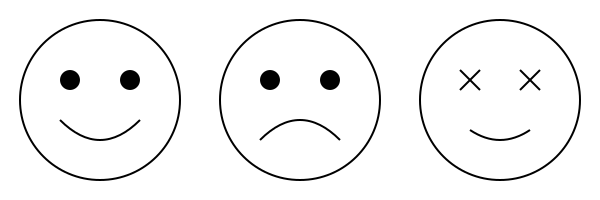As a theater director, you understand the importance of conveying emotions through facial expressions. Analyze the series of stylized face drawings above. Which of these expressions would be most appropriate for an actor portraying Konstantin Treplev during his final monologue in Chekhov's "The Seagull"? To answer this question, we need to consider the following steps:

1. Analyze the emotional expressions in the given drawings:
   a. Face 1 depicts joy or happiness (upturned mouth, open eyes)
   b. Face 2 shows sadness or melancholy (downturned mouth, drooping eyes)
   c. Face 3 represents anger or frustration (furrowed brow, tense mouth)

2. Recall the character of Konstantin Treplev in "The Seagull":
   - He is a young, aspiring playwright
   - He struggles with feelings of inadequacy and rejection
   - He is in love with Nina, who leaves him for another man

3. Consider the context of Treplev's final monologue:
   - It occurs near the end of the play
   - Treplev has become disillusioned with his art and life
   - He is about to commit suicide

4. Match the emotional state of Treplev to the appropriate facial expression:
   - Given his despair and hopelessness, the most fitting expression would be sadness or melancholy

5. Conclude that Face 2, depicting sadness, would be the most appropriate for an actor portraying Treplev during his final monologue.
Answer: Face 2 (sadness) 